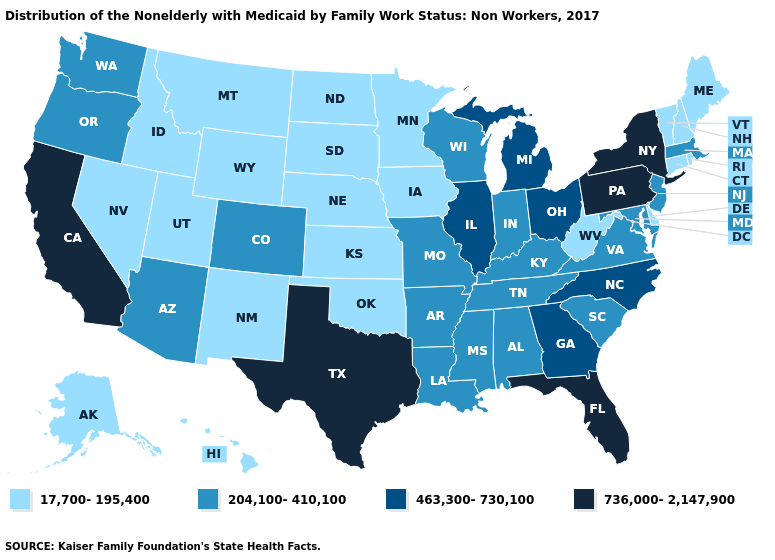What is the lowest value in the Northeast?
Give a very brief answer. 17,700-195,400. What is the highest value in states that border New Mexico?
Keep it brief. 736,000-2,147,900. What is the value of Missouri?
Concise answer only. 204,100-410,100. Does the map have missing data?
Keep it brief. No. What is the lowest value in states that border Nevada?
Write a very short answer. 17,700-195,400. Name the states that have a value in the range 204,100-410,100?
Give a very brief answer. Alabama, Arizona, Arkansas, Colorado, Indiana, Kentucky, Louisiana, Maryland, Massachusetts, Mississippi, Missouri, New Jersey, Oregon, South Carolina, Tennessee, Virginia, Washington, Wisconsin. What is the value of Colorado?
Concise answer only. 204,100-410,100. Does the map have missing data?
Short answer required. No. What is the value of Virginia?
Keep it brief. 204,100-410,100. Does Arkansas have a higher value than Virginia?
Keep it brief. No. What is the value of Michigan?
Short answer required. 463,300-730,100. Which states have the lowest value in the West?
Be succinct. Alaska, Hawaii, Idaho, Montana, Nevada, New Mexico, Utah, Wyoming. Among the states that border Alabama , does Mississippi have the lowest value?
Keep it brief. Yes. Name the states that have a value in the range 17,700-195,400?
Answer briefly. Alaska, Connecticut, Delaware, Hawaii, Idaho, Iowa, Kansas, Maine, Minnesota, Montana, Nebraska, Nevada, New Hampshire, New Mexico, North Dakota, Oklahoma, Rhode Island, South Dakota, Utah, Vermont, West Virginia, Wyoming. Does the map have missing data?
Write a very short answer. No. 